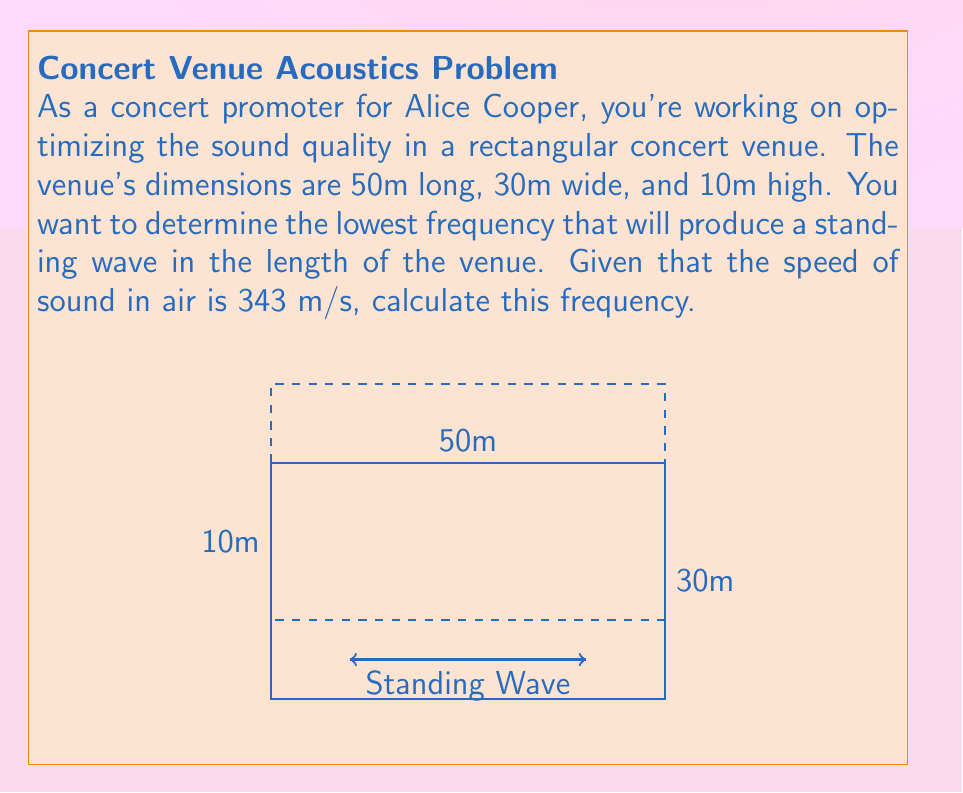Help me with this question. To solve this problem, we'll follow these steps:

1) The formula for the frequency of a standing wave in a rectangular room is:

   $$f = \frac{c}{2L}$$

   Where:
   $f$ is the frequency
   $c$ is the speed of sound
   $L$ is the length of the room in the direction of the wave

2) We're interested in the standing wave along the length of the room, so $L = 50$ m.

3) We're given that the speed of sound $c = 343$ m/s.

4) Substituting these values into our equation:

   $$f = \frac{343}{2(50)}$$

5) Simplifying:

   $$f = \frac{343}{100} = 3.43$$

Therefore, the lowest frequency that will produce a standing wave in the length of the venue is 3.43 Hz.
Answer: 3.43 Hz 